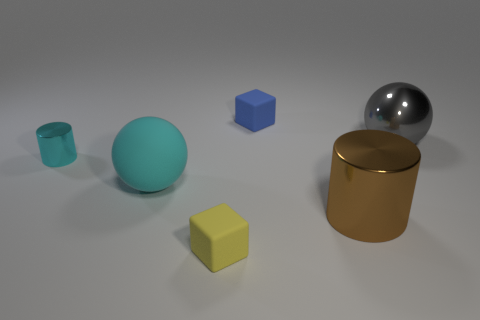Add 4 brown things. How many objects exist? 10 Subtract all spheres. How many objects are left? 4 Add 2 tiny matte objects. How many tiny matte objects exist? 4 Subtract 0 green blocks. How many objects are left? 6 Subtract all small purple objects. Subtract all big shiny things. How many objects are left? 4 Add 1 small metallic things. How many small metallic things are left? 2 